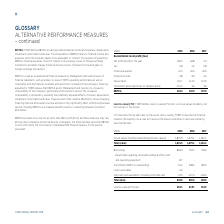According to Torm's financial document, How does TORM define EBITDA? as earnings before financial income and expenses, depreciation, impairment, amortization and taxes.. The document states: "EBITDA: TORM defines EBITDA as earnings before financial income and expenses, depreciation, impairment, amortization and taxes. The computation of EBI..." Also, What purpose is the EBITDA used for by Management and external users of financial statements, such as lenders? EBITDA is used as a supplemental financial measure by Management and external users of financial statements, such as lenders, to assess TORM's operating performance as well as compliance with the financial covenants and restrictions contained in the Company's financing agreements.. The document states: "income and gains on foreign exchange transactions. EBITDA is used as a supplemental financial measure by Management and external users of financial st..." Also, For which years in the table is the EBITDA reconciled to net profit/(loss)? The document contains multiple relevant values: 2019, 2018, 2017. From the document: "USDm 2019 2018 2017 USDm 2019 2018 2017 USDm 2019 2018 2017..." Additionally, In which year was the amount of Financial expenses the largest? According to the financial document, 2019. The relevant text states: "USDm 2019 2018 2017..." Also, can you calculate: What was the change in EBITDA in 2019 from 2018? Based on the calculation: 202.0-120.5, the result is 81.5 (in millions). This is based on the information: "EBITDA 202.0 120.5 157.6 EBITDA 202.0 120.5 157.6..." The key data points involved are: 120.5, 202.0. Also, can you calculate: What was the percentage change in EBITDA in 2019 from 2018? To answer this question, I need to perform calculations using the financial data. The calculation is: (202.0-120.5)/120.5, which equals 67.63 (percentage). This is based on the information: "EBITDA 202.0 120.5 157.6 EBITDA 202.0 120.5 157.6..." The key data points involved are: 120.5, 202.0. 